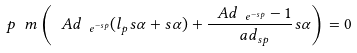<formula> <loc_0><loc_0><loc_500><loc_500>\ p _ { \ } m \left ( \ A d _ { \ e ^ { - s p } } ( l _ { p } s \alpha + s \alpha ) + \frac { \ A d _ { \ e ^ { - s p } } - 1 } { \ a d _ { s p } } s \alpha \right ) = 0</formula> 